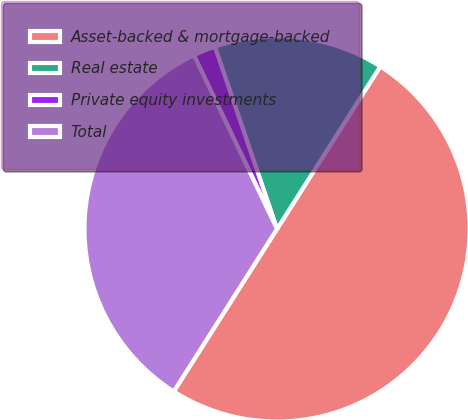Convert chart to OTSL. <chart><loc_0><loc_0><loc_500><loc_500><pie_chart><fcel>Asset-backed & mortgage-backed<fcel>Real estate<fcel>Private equity investments<fcel>Total<nl><fcel>50.0%<fcel>14.24%<fcel>1.87%<fcel>33.89%<nl></chart> 